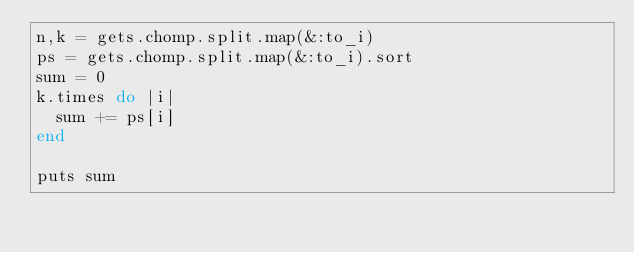Convert code to text. <code><loc_0><loc_0><loc_500><loc_500><_Ruby_>n,k = gets.chomp.split.map(&:to_i)
ps = gets.chomp.split.map(&:to_i).sort
sum = 0
k.times do |i|
  sum += ps[i]
end

puts sum
</code> 